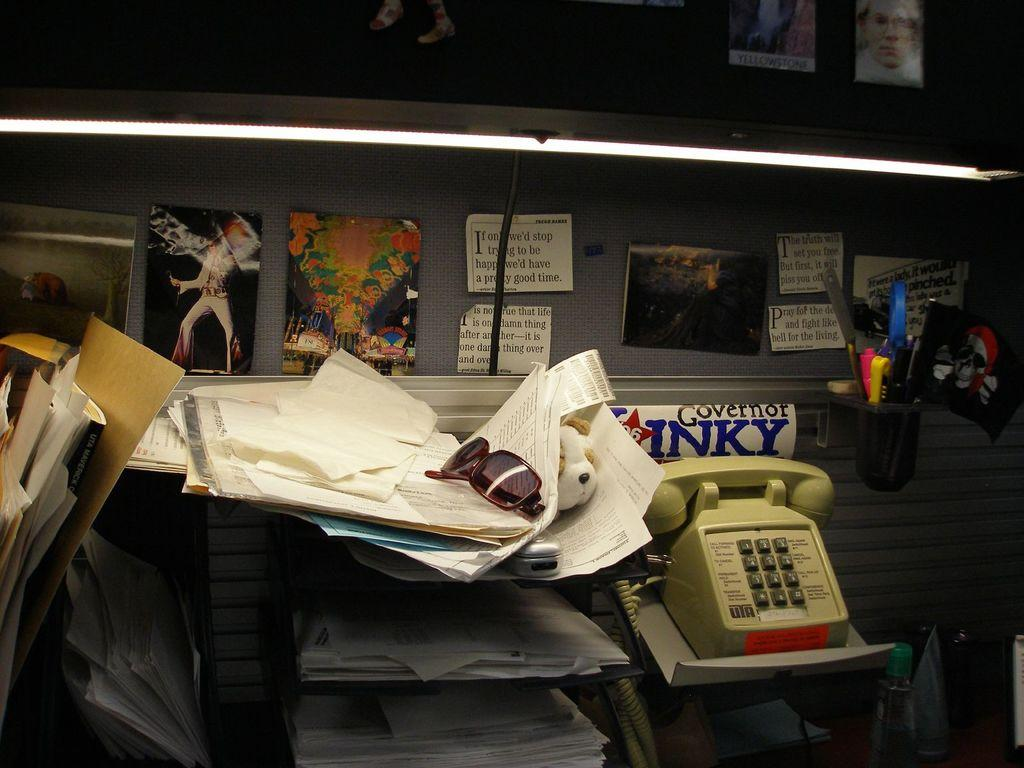What object is located on the right side of the image? There is a telephone on the right side of the image. What can be seen on the left side of the image? There are papers on the left side of the image. What is hanging on the wall in the image? There are photographs on a wall in the image. Is there a pipe visible in the image? No, there is no pipe present in the image. Can you see any crackers in the image? No, there are no crackers visible in the image. 